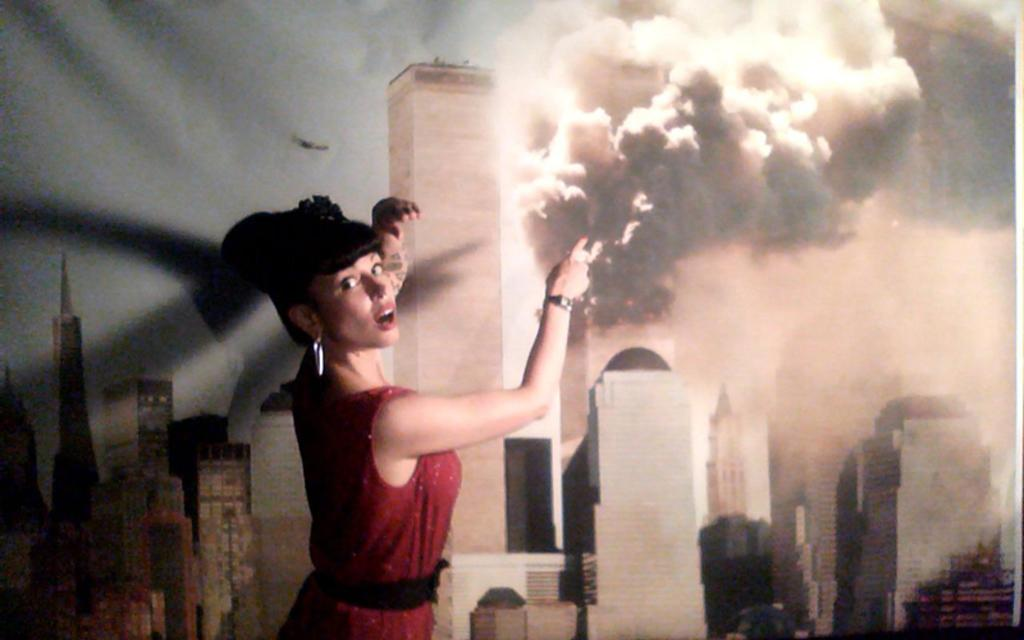What is the main subject of the image? There is a woman standing in the image. Where is the woman positioned in the image? The woman is standing at a wall. What can be seen on the wall in the image? There is a painting of buildings on the wall in the image. What is visible in the sky in the image? There is an aircraft in the sky in the image. What type of fruit is falling from the tail of the aircraft in the image? There is no fruit falling from the tail of the aircraft in the image, nor is there any mention of a tail in the provided facts. --- 